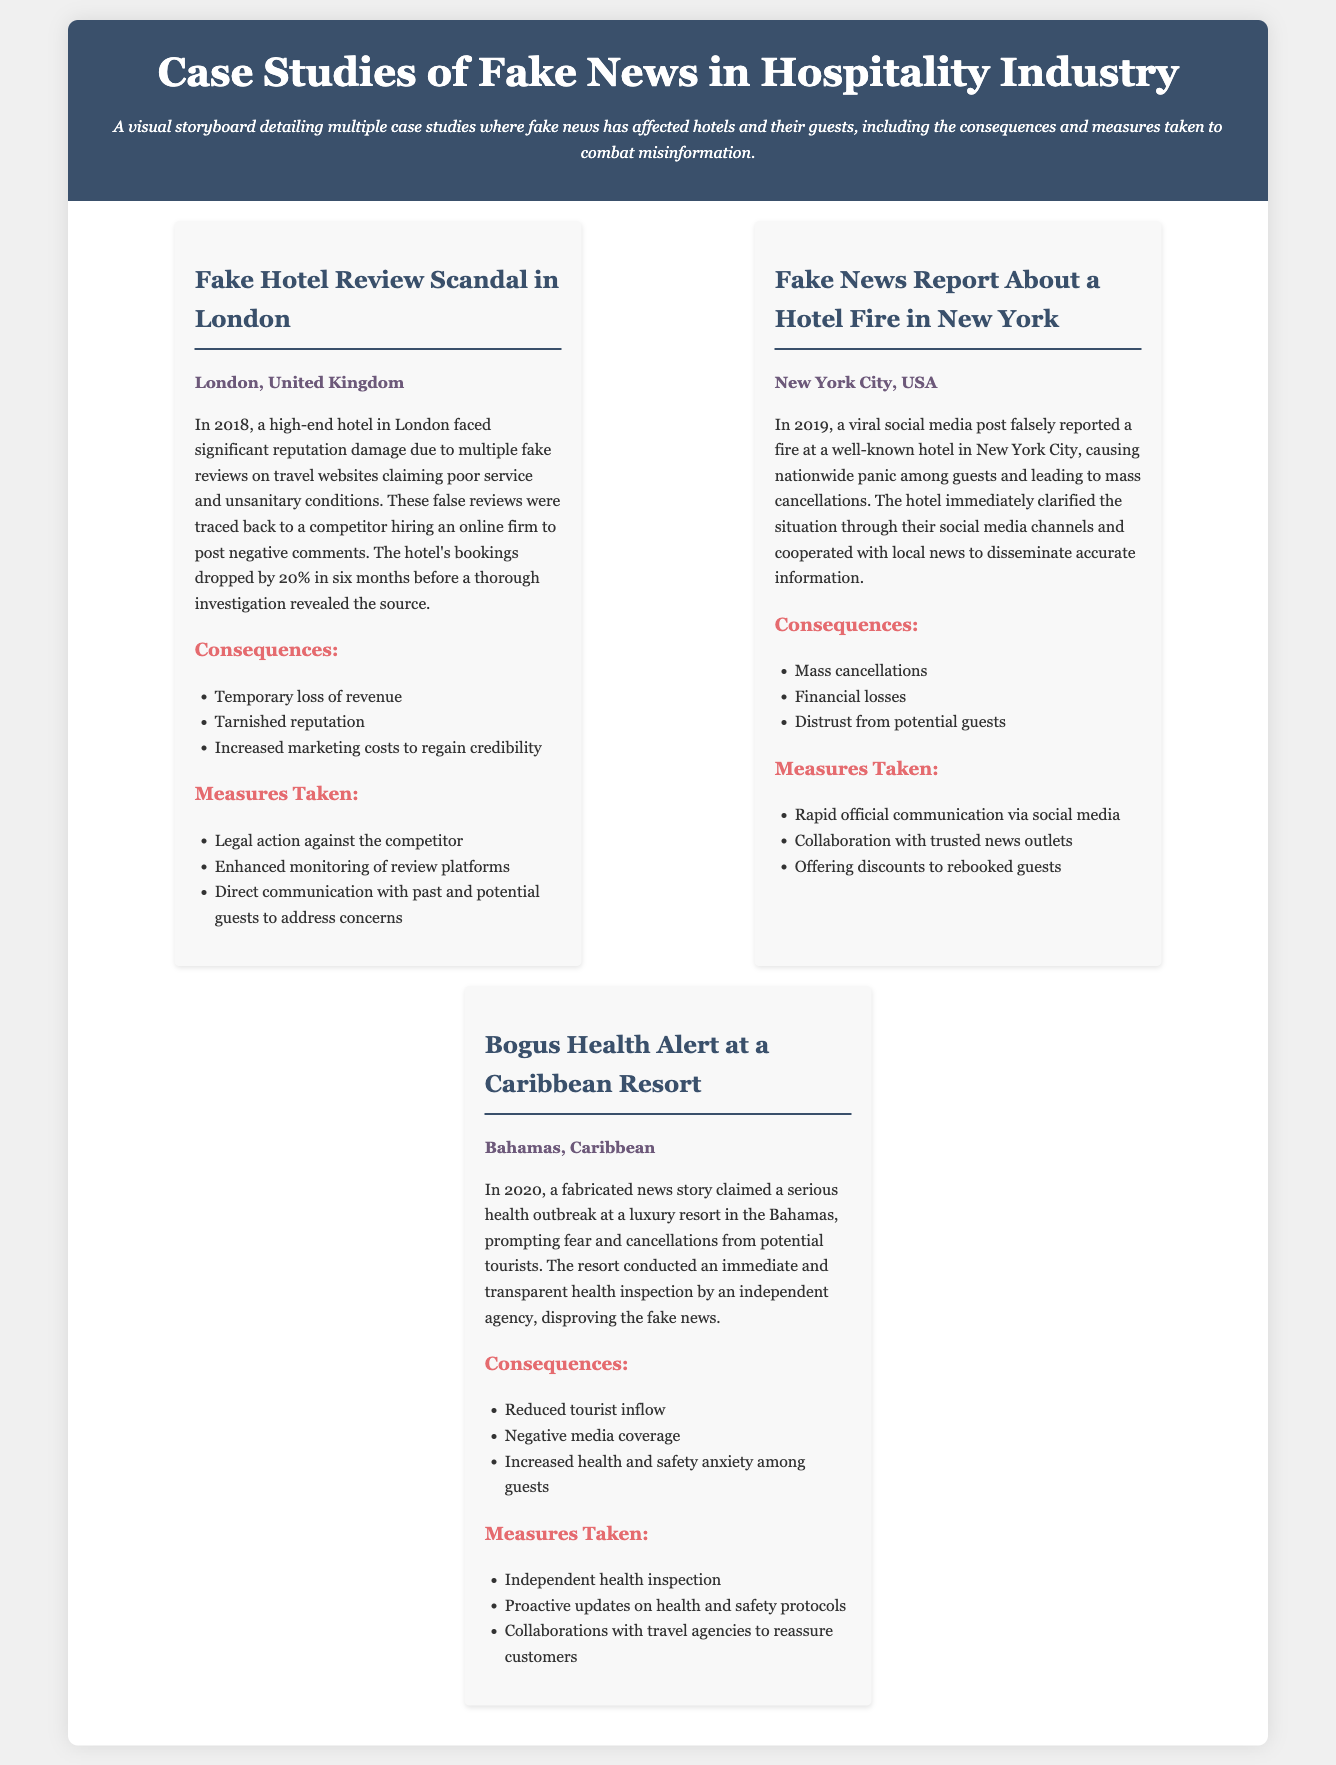What is the location of the fake hotel review scandal? The location specified for the fake hotel review scandal is London, United Kingdom.
Answer: London, United Kingdom What year did the fake news report about the hotel fire occur? The year in which the fake news report about the hotel fire in New York City occurred is 2019.
Answer: 2019 What was one of the consequences of the bogus health alert at the Caribbean resort? One of the consequences listed for the bogus health alert at the Caribbean resort was reduced tourist inflow.
Answer: Reduced tourist inflow What measures did the luxury resort in the Bahamas take to combat the fake news? The measures taken by the luxury resort included an independent health inspection.
Answer: Independent health inspection What percentage did the London hotel's bookings drop by due to fake reviews? The document states that the bookings of the hotel in London dropped by 20%.
Answer: 20% What immediate action did the New York hotel take after the fire hoax? The New York hotel immediately clarified the situation through their social media channels.
Answer: Social media channels How did the hotel in London respond to the fake reviews? The hotel took legal action against the competitor for the fake reviews.
Answer: Legal action What type of news spread about the Caribbean resort in 2020? The type of news that spread about the Caribbean resort in 2020 was a fabricated health story.
Answer: Fabricated health story 